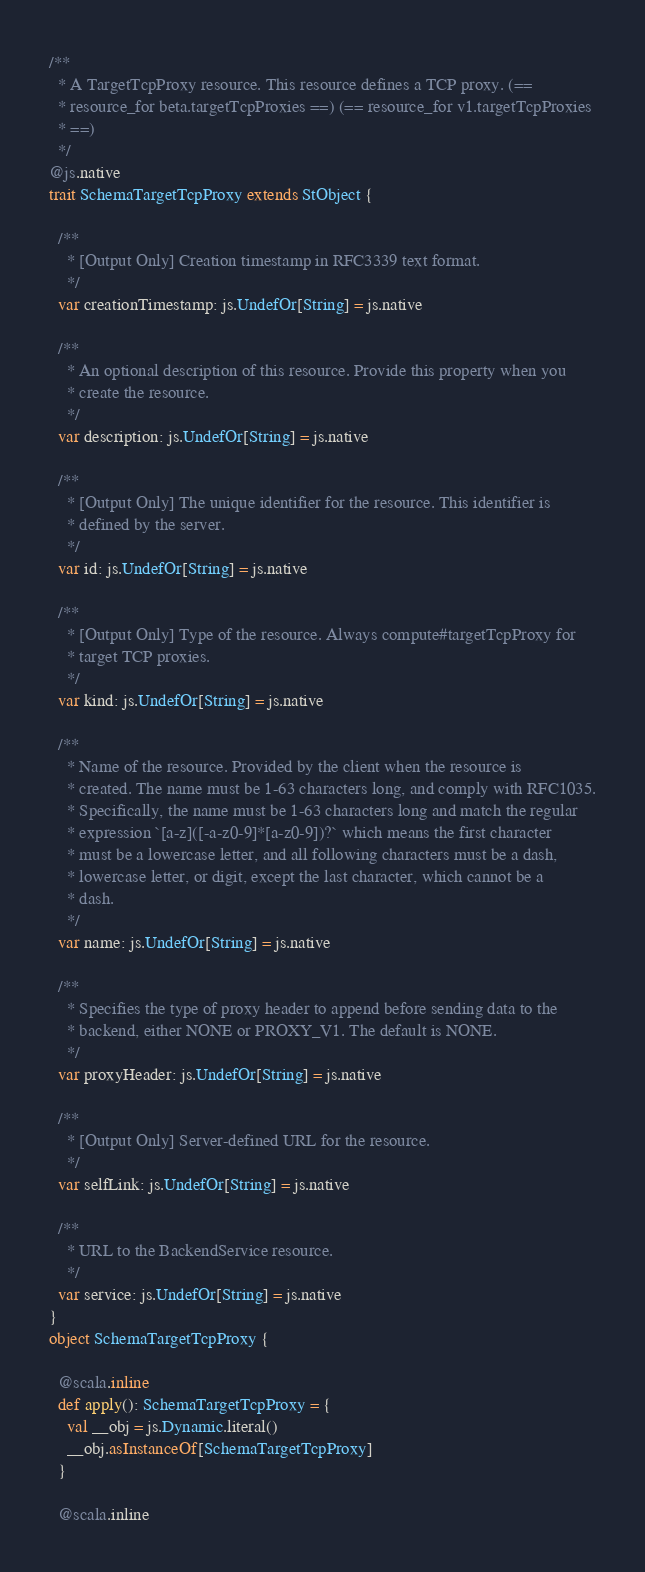<code> <loc_0><loc_0><loc_500><loc_500><_Scala_>
/**
  * A TargetTcpProxy resource. This resource defines a TCP proxy. (==
  * resource_for beta.targetTcpProxies ==) (== resource_for v1.targetTcpProxies
  * ==)
  */
@js.native
trait SchemaTargetTcpProxy extends StObject {
  
  /**
    * [Output Only] Creation timestamp in RFC3339 text format.
    */
  var creationTimestamp: js.UndefOr[String] = js.native
  
  /**
    * An optional description of this resource. Provide this property when you
    * create the resource.
    */
  var description: js.UndefOr[String] = js.native
  
  /**
    * [Output Only] The unique identifier for the resource. This identifier is
    * defined by the server.
    */
  var id: js.UndefOr[String] = js.native
  
  /**
    * [Output Only] Type of the resource. Always compute#targetTcpProxy for
    * target TCP proxies.
    */
  var kind: js.UndefOr[String] = js.native
  
  /**
    * Name of the resource. Provided by the client when the resource is
    * created. The name must be 1-63 characters long, and comply with RFC1035.
    * Specifically, the name must be 1-63 characters long and match the regular
    * expression `[a-z]([-a-z0-9]*[a-z0-9])?` which means the first character
    * must be a lowercase letter, and all following characters must be a dash,
    * lowercase letter, or digit, except the last character, which cannot be a
    * dash.
    */
  var name: js.UndefOr[String] = js.native
  
  /**
    * Specifies the type of proxy header to append before sending data to the
    * backend, either NONE or PROXY_V1. The default is NONE.
    */
  var proxyHeader: js.UndefOr[String] = js.native
  
  /**
    * [Output Only] Server-defined URL for the resource.
    */
  var selfLink: js.UndefOr[String] = js.native
  
  /**
    * URL to the BackendService resource.
    */
  var service: js.UndefOr[String] = js.native
}
object SchemaTargetTcpProxy {
  
  @scala.inline
  def apply(): SchemaTargetTcpProxy = {
    val __obj = js.Dynamic.literal()
    __obj.asInstanceOf[SchemaTargetTcpProxy]
  }
  
  @scala.inline</code> 